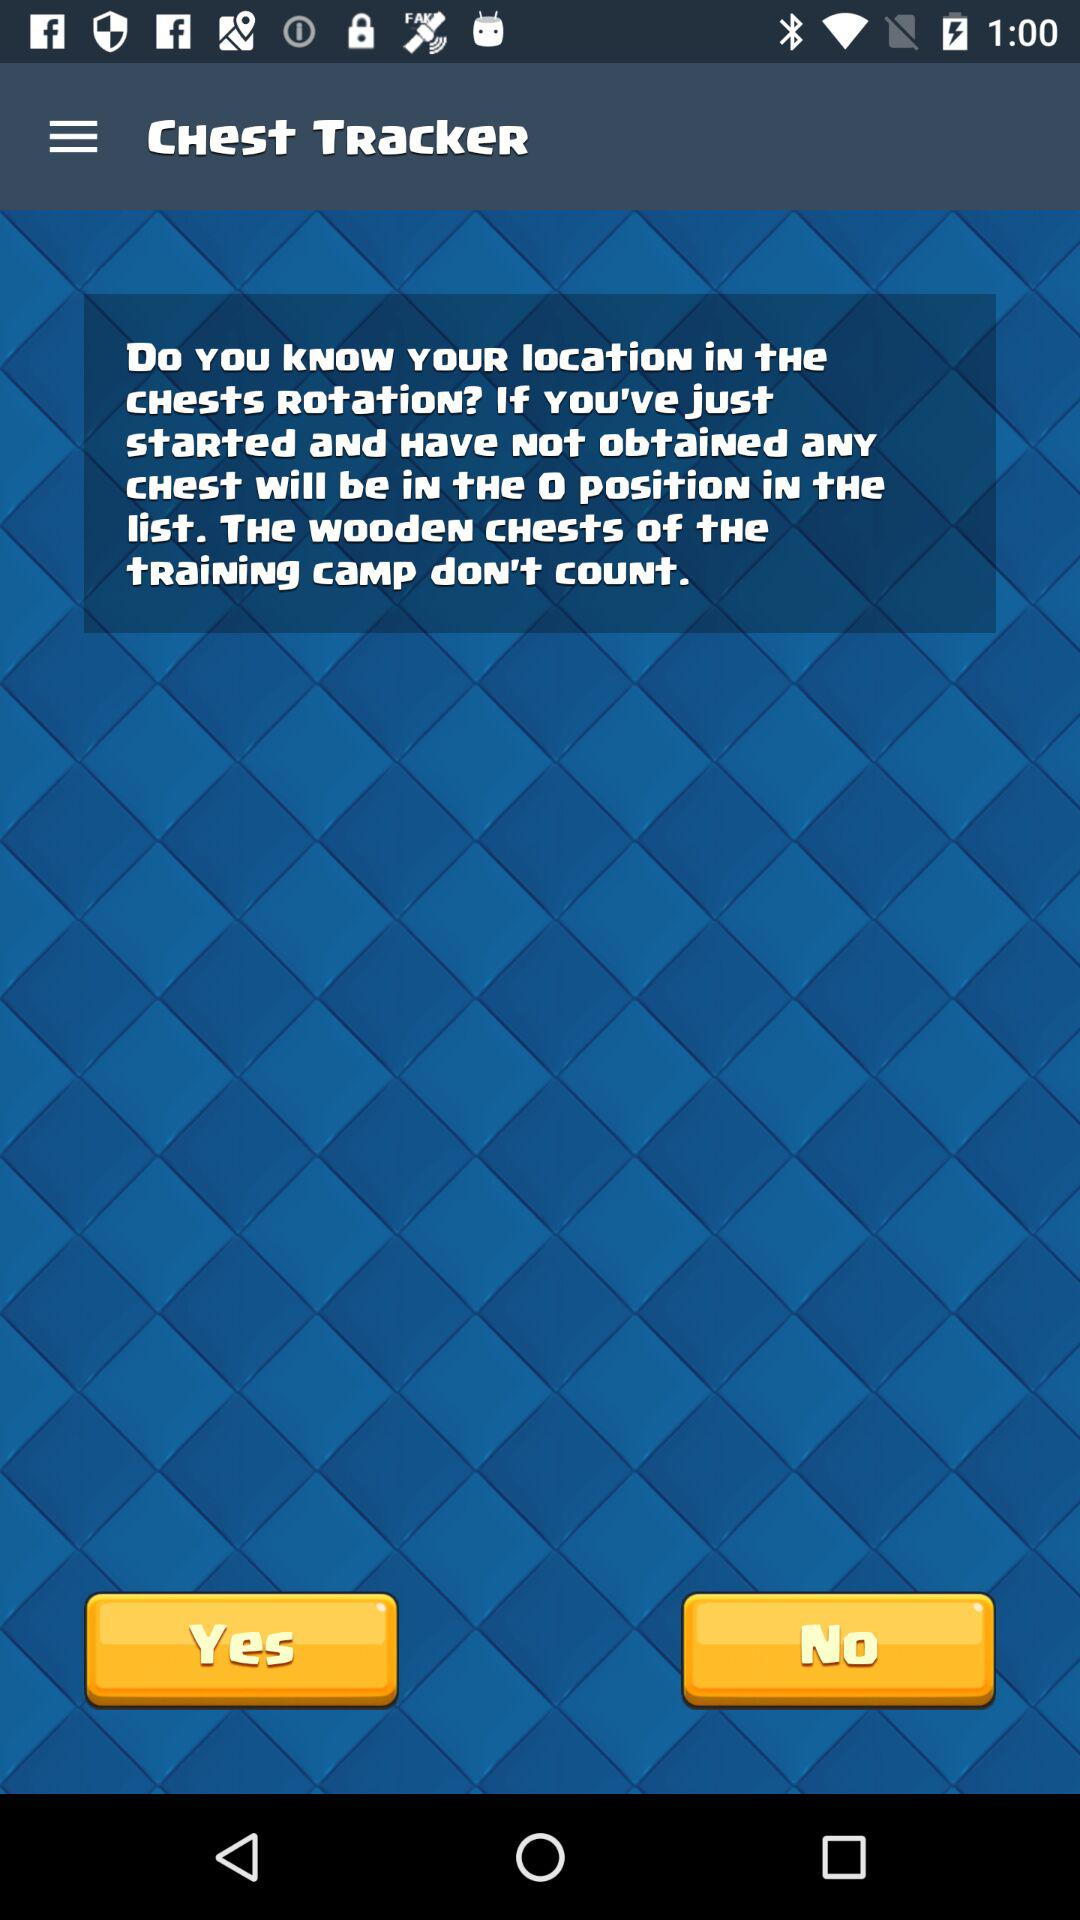What is the application name? The application name is "Chest Tracker". 